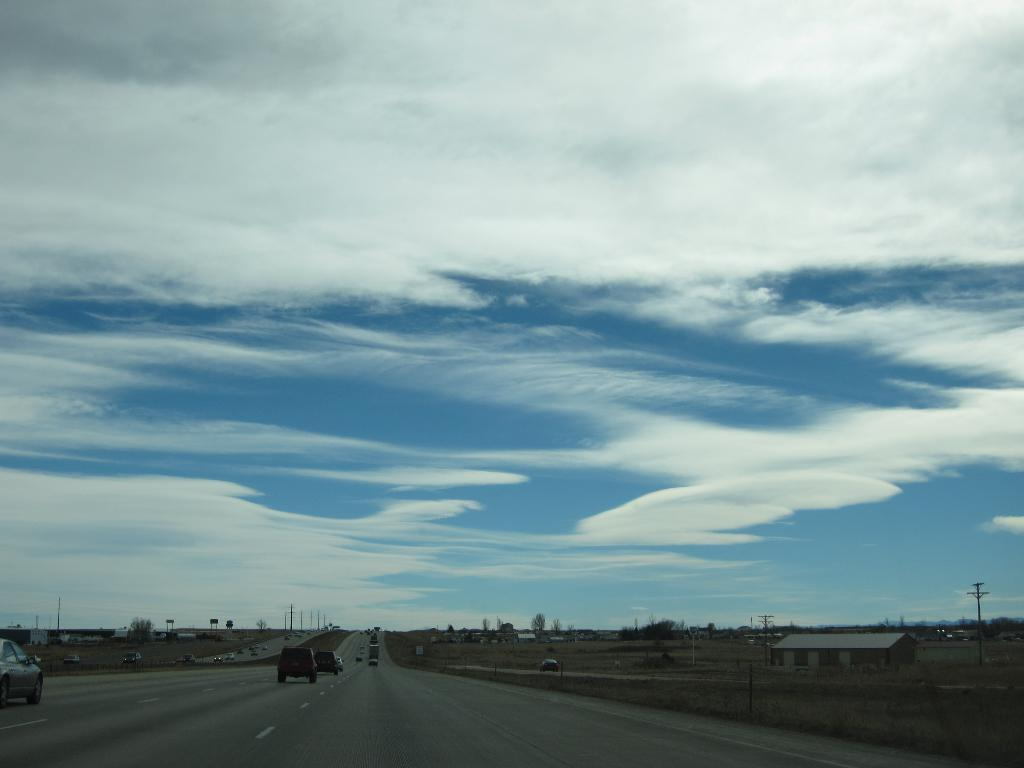What can be seen on the road in the image? There are motor vehicles on the road in the image. What structures are present to control traffic in the image? Barrier poles are present in the image. What type of buildings can be seen on the ground? There are sheds on the ground in the image. What infrastructure is visible for providing electricity? Electric poles are visible in the image. What type of signage is present to provide information? Information boards are present in the image. What is visible in the sky in the image? The sky is visible with clouds in the image. How many cherries are hanging from the electric poles in the image? There are no cherries present in the image; it features electric poles and other infrastructure. What type of payment system is in place for the motor vehicles in the image? There is no information about a payment system for the motor vehicles in the image. 